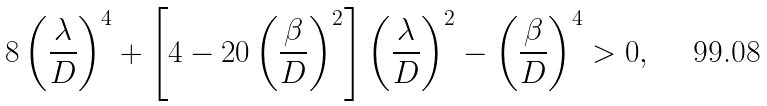Convert formula to latex. <formula><loc_0><loc_0><loc_500><loc_500>8 \left ( \frac { \lambda } { D } \right ) ^ { 4 } + \left [ 4 - 2 0 \left ( \frac { \beta } { D } \right ) ^ { 2 } \right ] \left ( \frac { \lambda } { D } \right ) ^ { 2 } - \left ( \frac { \beta } { D } \right ) ^ { 4 } > 0 ,</formula> 